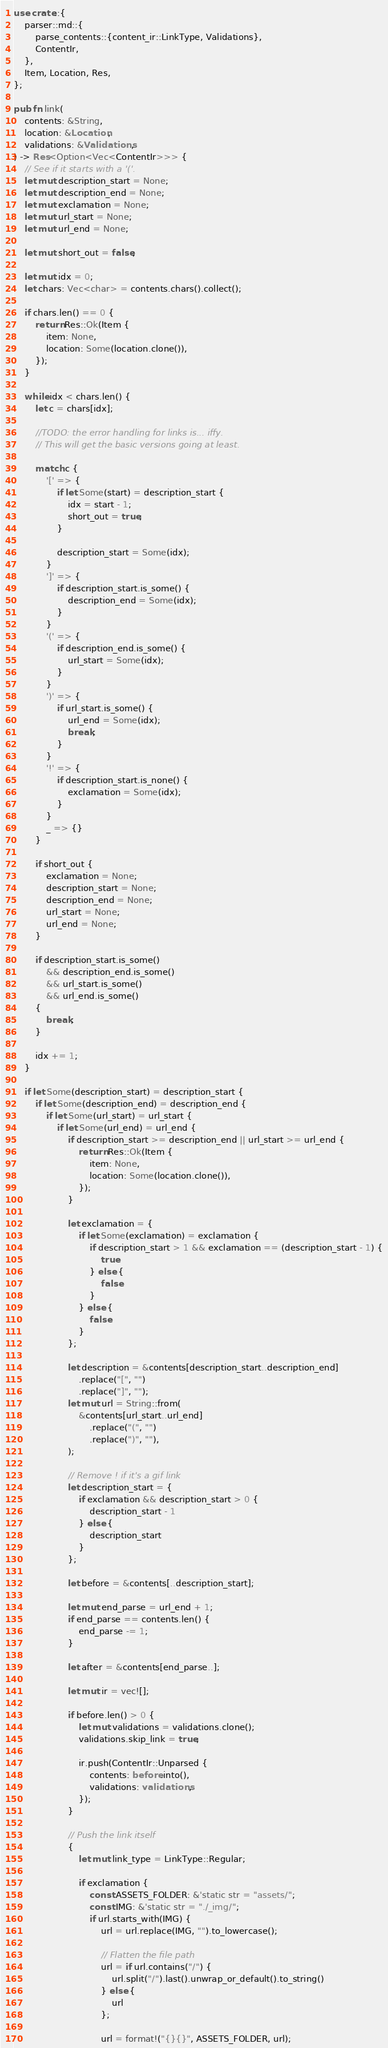Convert code to text. <code><loc_0><loc_0><loc_500><loc_500><_Rust_>use crate::{
    parser::md::{
        parse_contents::{content_ir::LinkType, Validations},
        ContentIr,
    },
    Item, Location, Res,
};

pub fn link(
    contents: &String,
    location: &Location,
    validations: &Validations,
) -> Res<Option<Vec<ContentIr>>> {
    // See if it starts with a '('.
    let mut description_start = None;
    let mut description_end = None;
    let mut exclamation = None;
    let mut url_start = None;
    let mut url_end = None;

    let mut short_out = false;

    let mut idx = 0;
    let chars: Vec<char> = contents.chars().collect();

    if chars.len() == 0 {
        return Res::Ok(Item {
            item: None,
            location: Some(location.clone()),
        });
    }

    while idx < chars.len() {
        let c = chars[idx];

        //TODO: the error handling for links is... iffy.
        // This will get the basic versions going at least.

        match c {
            '[' => {
                if let Some(start) = description_start {
                    idx = start - 1;
                    short_out = true;
                }

                description_start = Some(idx);
            }
            ']' => {
                if description_start.is_some() {
                    description_end = Some(idx);
                }
            }
            '(' => {
                if description_end.is_some() {
                    url_start = Some(idx);
                }
            }
            ')' => {
                if url_start.is_some() {
                    url_end = Some(idx);
                    break;
                }
            }
            '!' => {
                if description_start.is_none() {
                    exclamation = Some(idx);
                }
            }
            _ => {}
        }

        if short_out {
            exclamation = None;
            description_start = None;
            description_end = None;
            url_start = None;
            url_end = None;
        }

        if description_start.is_some()
            && description_end.is_some()
            && url_start.is_some()
            && url_end.is_some()
        {
            break;
        }

        idx += 1;
    }

    if let Some(description_start) = description_start {
        if let Some(description_end) = description_end {
            if let Some(url_start) = url_start {
                if let Some(url_end) = url_end {
                    if description_start >= description_end || url_start >= url_end {
                        return Res::Ok(Item {
                            item: None,
                            location: Some(location.clone()),
                        });
                    }

                    let exclamation = {
                        if let Some(exclamation) = exclamation {
                            if description_start > 1 && exclamation == (description_start - 1) {
                                true
                            } else {
                                false
                            }
                        } else {
                            false
                        }
                    };

                    let description = &contents[description_start..description_end]
                        .replace("[", "")
                        .replace("]", "");
                    let mut url = String::from(
                        &contents[url_start..url_end]
                            .replace("(", "")
                            .replace(")", ""),
                    );

                    // Remove ! if it's a gif link
                    let description_start = {
                        if exclamation && description_start > 0 {
                            description_start - 1
                        } else {
                            description_start
                        }
                    };

                    let before = &contents[..description_start];

                    let mut end_parse = url_end + 1;
                    if end_parse == contents.len() {
                        end_parse -= 1;
                    }

                    let after = &contents[end_parse..];

                    let mut ir = vec![];

                    if before.len() > 0 {
                        let mut validations = validations.clone();
                        validations.skip_link = true;

                        ir.push(ContentIr::Unparsed {
                            contents: before.into(),
                            validations: validations,
                        });
                    }

                    // Push the link itself
                    {
                        let mut link_type = LinkType::Regular;

                        if exclamation {
                            const ASSETS_FOLDER: &'static str = "assets/";
                            const IMG: &'static str = "./_img/";
                            if url.starts_with(IMG) {
                                url = url.replace(IMG, "").to_lowercase();

                                // Flatten the file path
                                url = if url.contains("/") {
                                    url.split("/").last().unwrap_or_default().to_string()
                                } else {
                                    url
                                };

                                url = format!("{}{}", ASSETS_FOLDER, url);
</code> 